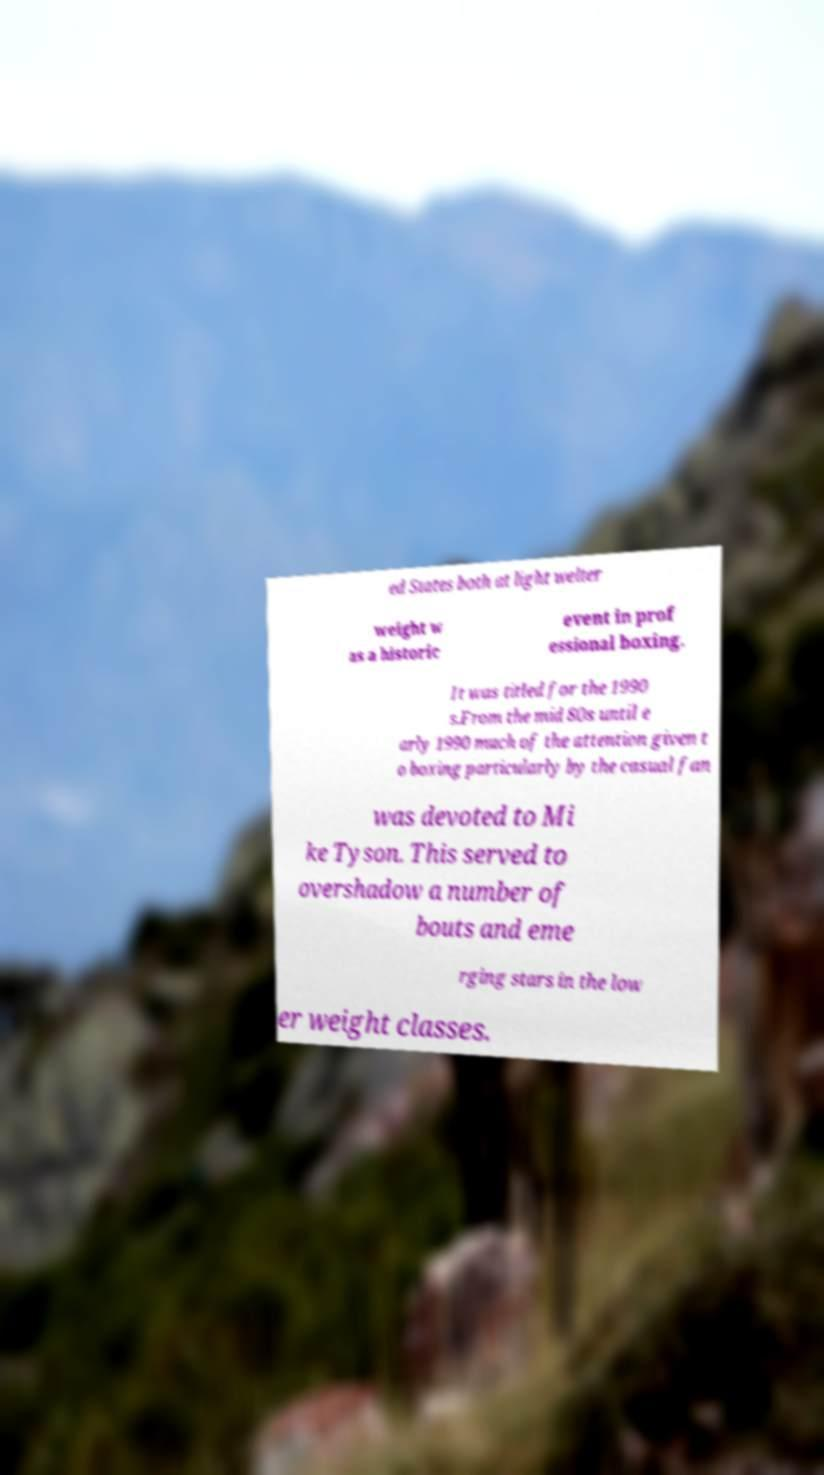Can you accurately transcribe the text from the provided image for me? ed States both at light welter weight w as a historic event in prof essional boxing. It was titled for the 1990 s.From the mid 80s until e arly 1990 much of the attention given t o boxing particularly by the casual fan was devoted to Mi ke Tyson. This served to overshadow a number of bouts and eme rging stars in the low er weight classes. 